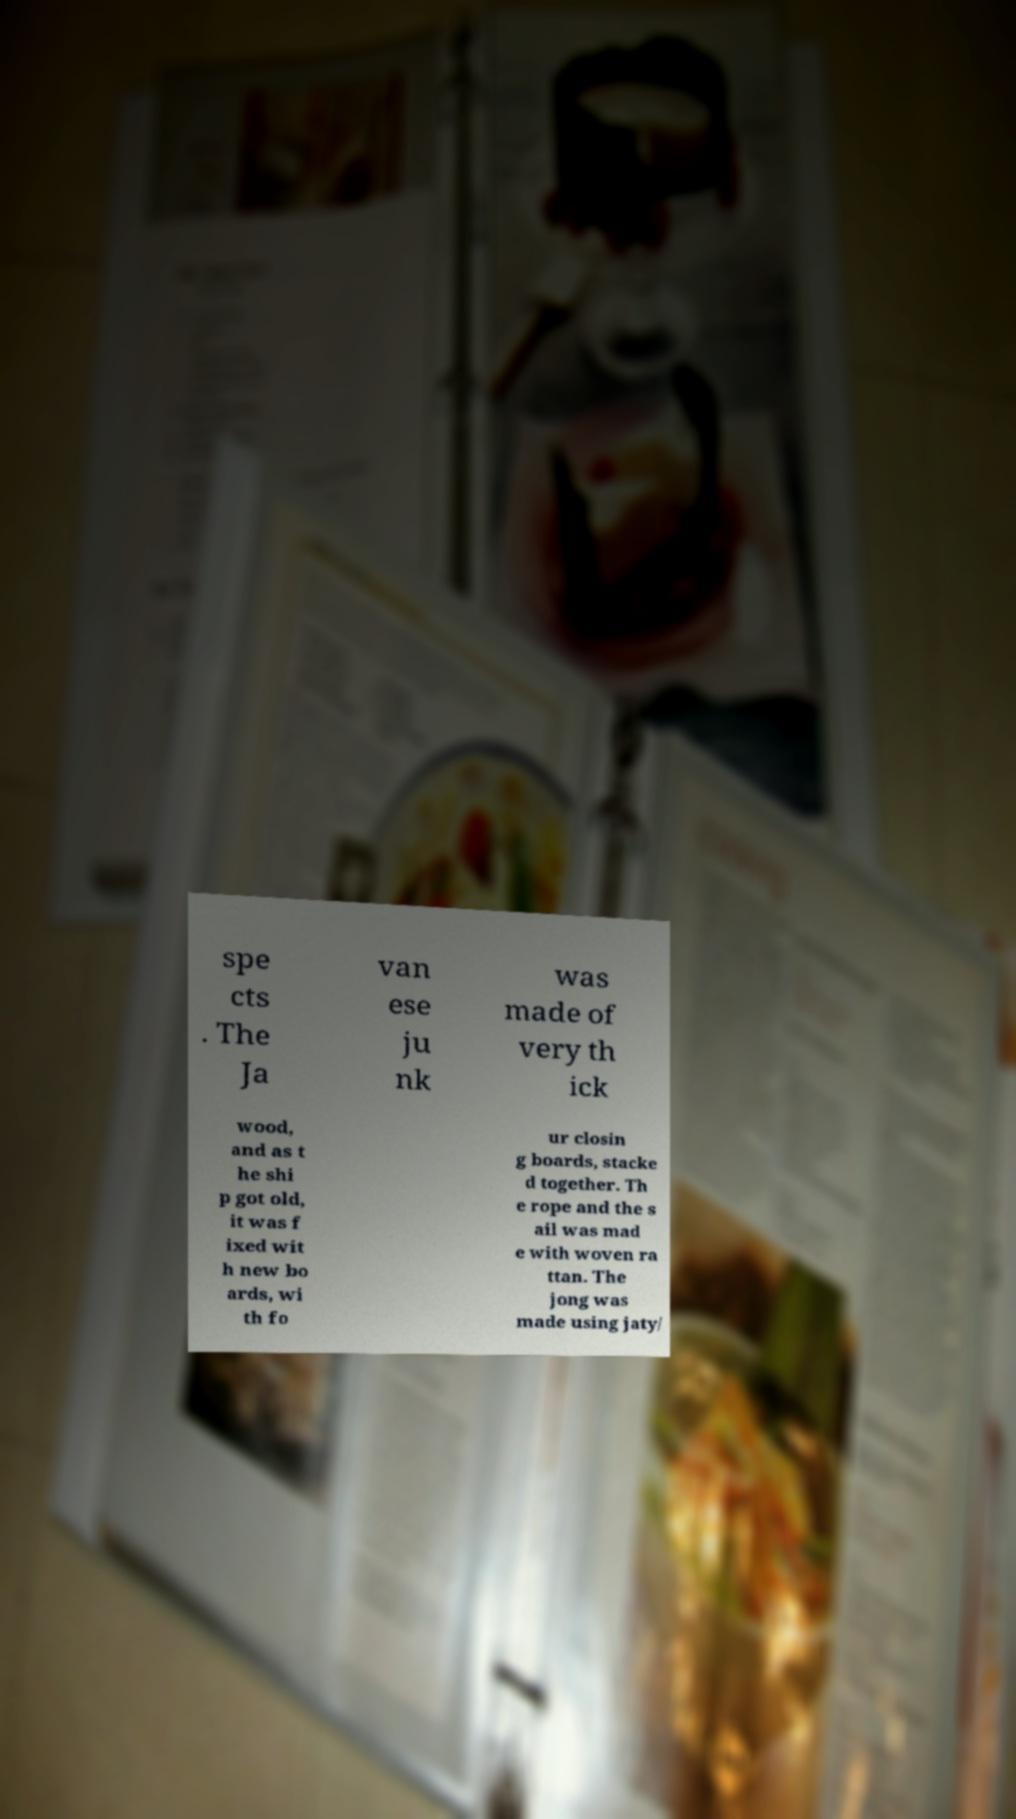Please identify and transcribe the text found in this image. spe cts . The Ja van ese ju nk was made of very th ick wood, and as t he shi p got old, it was f ixed wit h new bo ards, wi th fo ur closin g boards, stacke d together. Th e rope and the s ail was mad e with woven ra ttan. The jong was made using jaty/ 